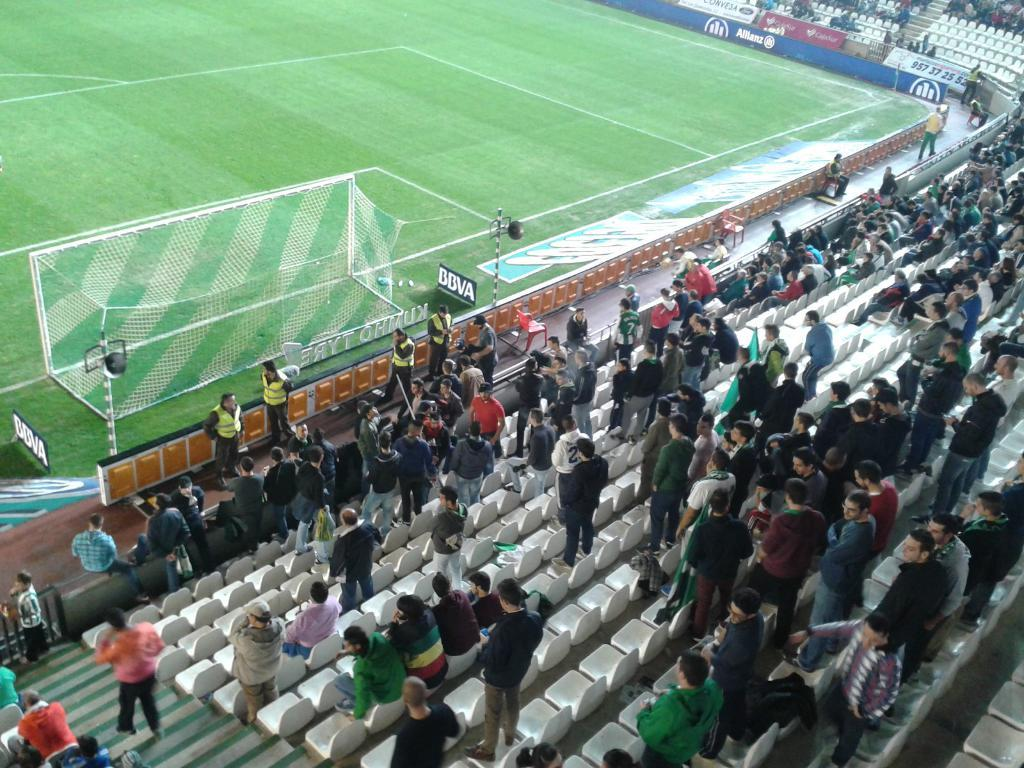What are the people in the image doing? There are people standing and sitting in the image. What can be seen in the background of the image? There are lights, a net, fencing, and stairs visible in the image. What type of decorations are present in the image? There are colorful banners in the image. Can you tell me how many horses are present in the image? There are no horses present in the image. Where is the building located in the image? There is no building present in the image. 